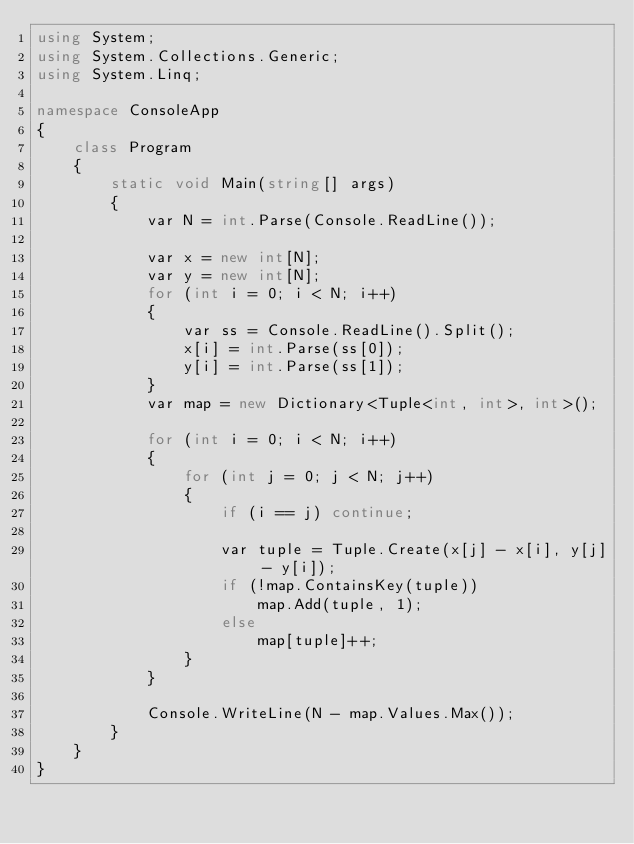<code> <loc_0><loc_0><loc_500><loc_500><_C#_>using System;
using System.Collections.Generic;
using System.Linq;

namespace ConsoleApp
{
    class Program
    {
        static void Main(string[] args)
        {
            var N = int.Parse(Console.ReadLine());

            var x = new int[N];
            var y = new int[N];
            for (int i = 0; i < N; i++)
            {
                var ss = Console.ReadLine().Split();
                x[i] = int.Parse(ss[0]);
                y[i] = int.Parse(ss[1]);
            }
            var map = new Dictionary<Tuple<int, int>, int>();

            for (int i = 0; i < N; i++)
            {
                for (int j = 0; j < N; j++)
                {
                    if (i == j) continue;

                    var tuple = Tuple.Create(x[j] - x[i], y[j] - y[i]);
                    if (!map.ContainsKey(tuple))
                        map.Add(tuple, 1);
                    else
                        map[tuple]++;
                }
            }

            Console.WriteLine(N - map.Values.Max());
        }
    }
}</code> 